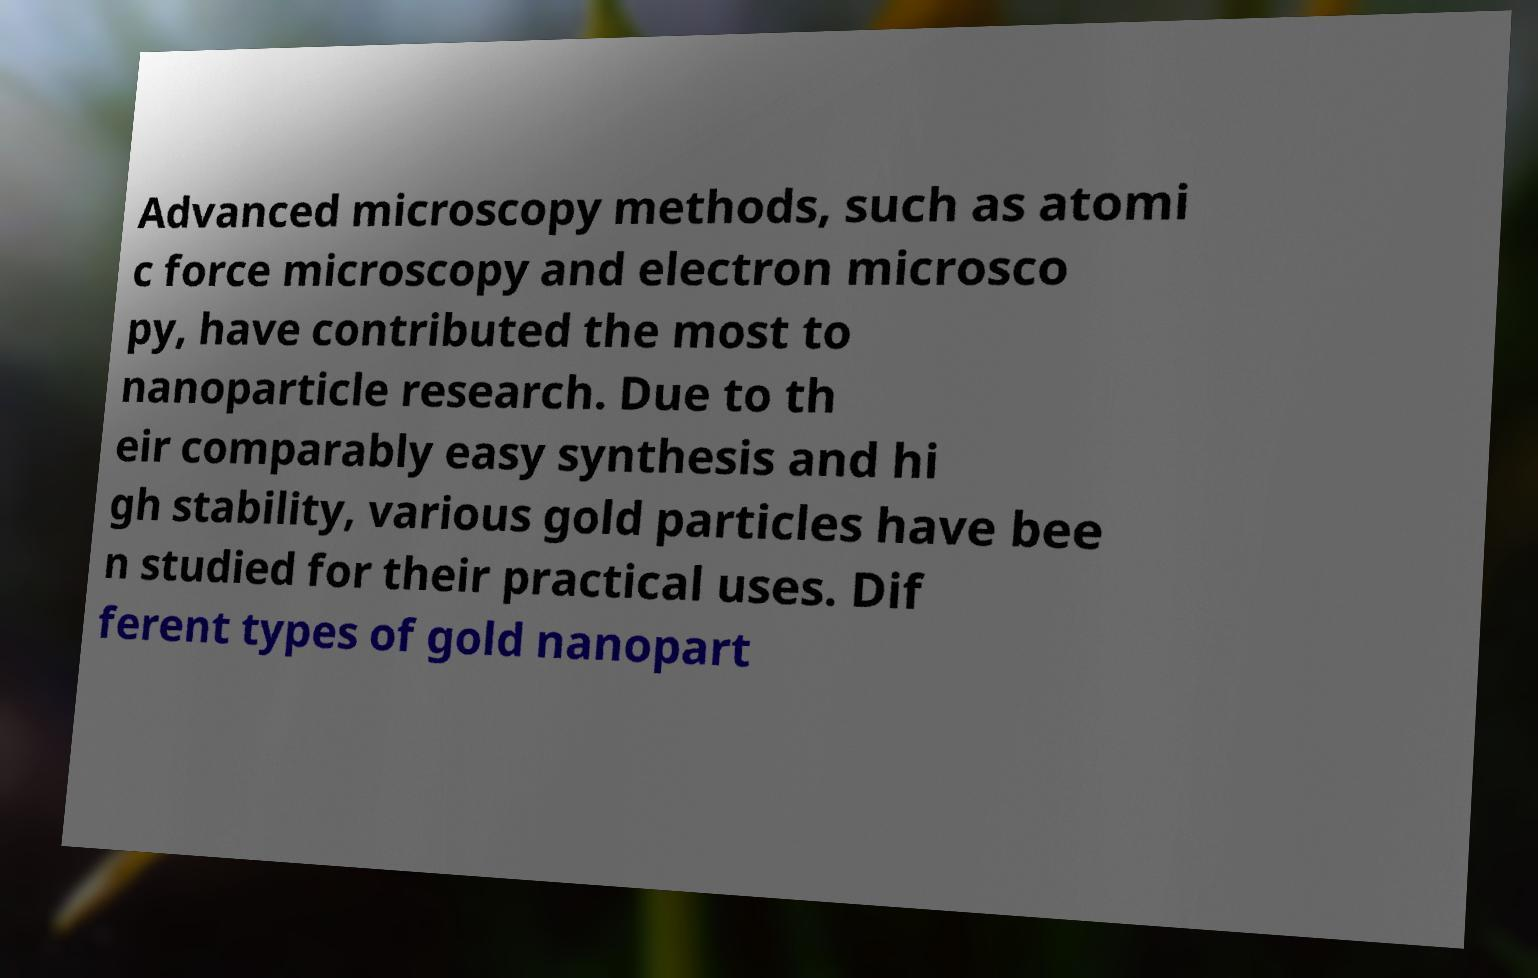Could you extract and type out the text from this image? Advanced microscopy methods, such as atomi c force microscopy and electron microsco py, have contributed the most to nanoparticle research. Due to th eir comparably easy synthesis and hi gh stability, various gold particles have bee n studied for their practical uses. Dif ferent types of gold nanopart 